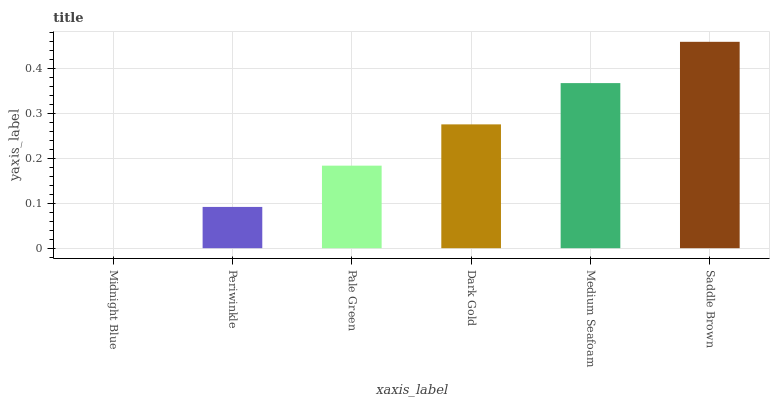Is Midnight Blue the minimum?
Answer yes or no. Yes. Is Saddle Brown the maximum?
Answer yes or no. Yes. Is Periwinkle the minimum?
Answer yes or no. No. Is Periwinkle the maximum?
Answer yes or no. No. Is Periwinkle greater than Midnight Blue?
Answer yes or no. Yes. Is Midnight Blue less than Periwinkle?
Answer yes or no. Yes. Is Midnight Blue greater than Periwinkle?
Answer yes or no. No. Is Periwinkle less than Midnight Blue?
Answer yes or no. No. Is Dark Gold the high median?
Answer yes or no. Yes. Is Pale Green the low median?
Answer yes or no. Yes. Is Pale Green the high median?
Answer yes or no. No. Is Saddle Brown the low median?
Answer yes or no. No. 